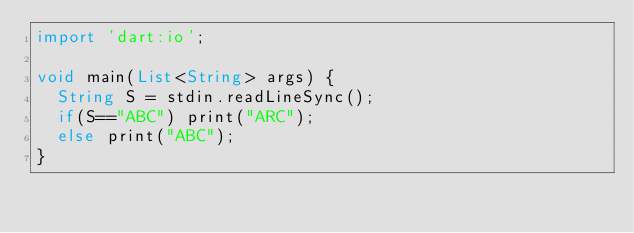<code> <loc_0><loc_0><loc_500><loc_500><_Dart_>import 'dart:io';
 
void main(List<String> args) {
  String S = stdin.readLineSync();
  if(S=="ABC") print("ARC");
  else print("ABC");
}</code> 